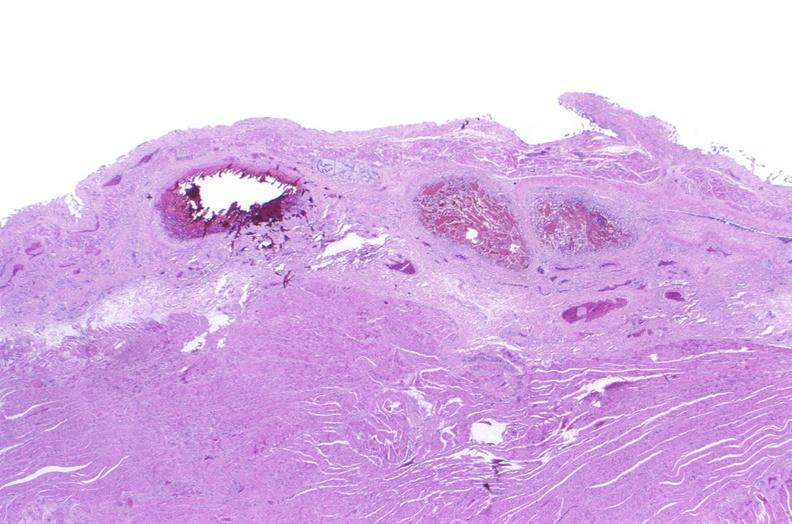does this image show esophagus, varices?
Answer the question using a single word or phrase. Yes 